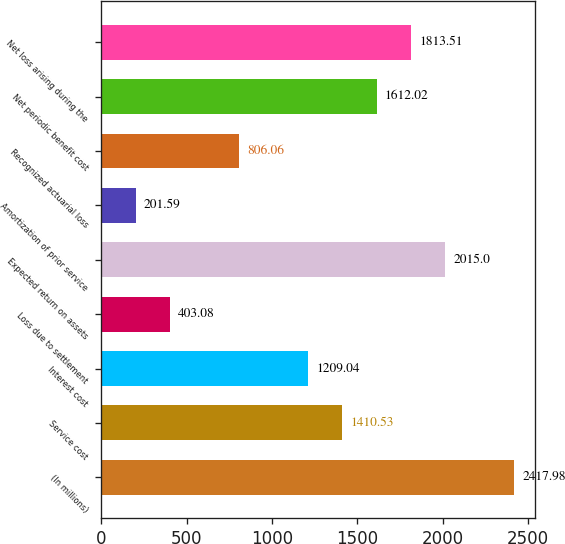<chart> <loc_0><loc_0><loc_500><loc_500><bar_chart><fcel>(In millions)<fcel>Service cost<fcel>Interest cost<fcel>Loss due to settlement<fcel>Expected return on assets<fcel>Amortization of prior service<fcel>Recognized actuarial loss<fcel>Net periodic benefit cost<fcel>Net loss arising during the<nl><fcel>2417.98<fcel>1410.53<fcel>1209.04<fcel>403.08<fcel>2015<fcel>201.59<fcel>806.06<fcel>1612.02<fcel>1813.51<nl></chart> 